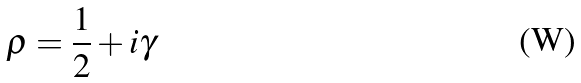Convert formula to latex. <formula><loc_0><loc_0><loc_500><loc_500>\rho = { \frac { 1 } { 2 } } + i \gamma</formula> 